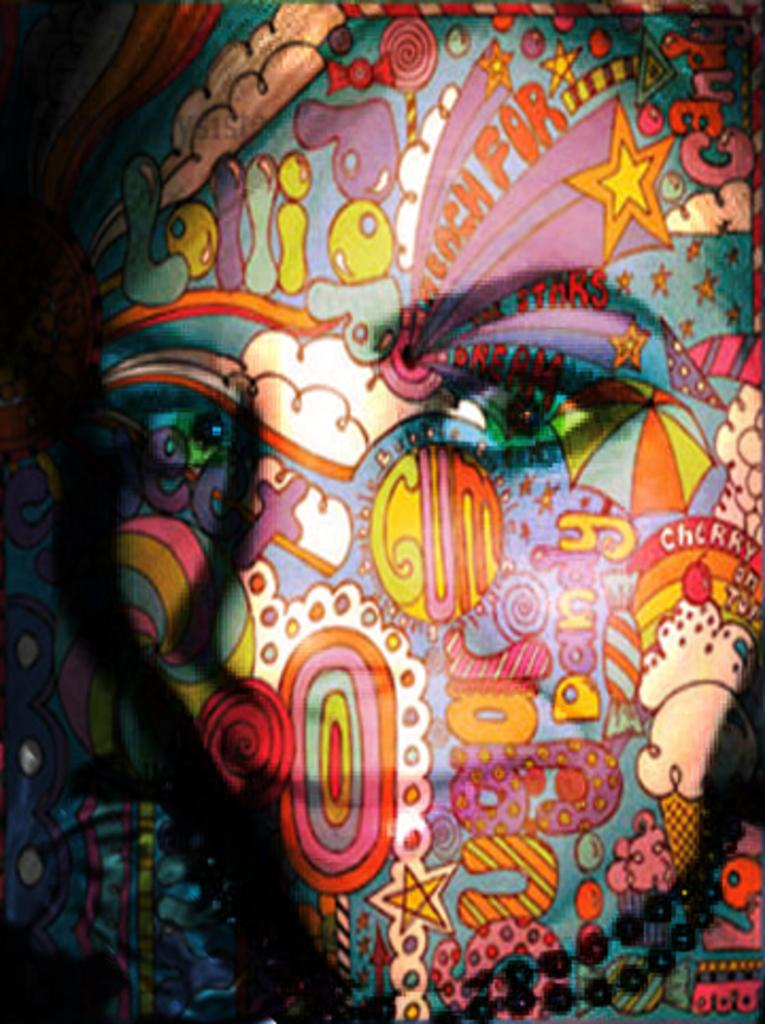Who is the main subject in the image? There is a girl in the image. Can you describe the appearance of the image? The image appears to be edited, and it contains many colors. What type of industry can be seen in the background of the image? There is no industry visible in the image; it only features a girl. How many dogs are present in the image? There are no dogs present in the image; it only features a girl. 